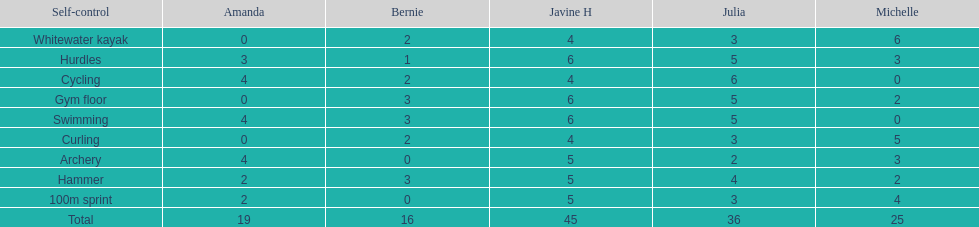Which of the girls had the least amount in archery? Bernie. 